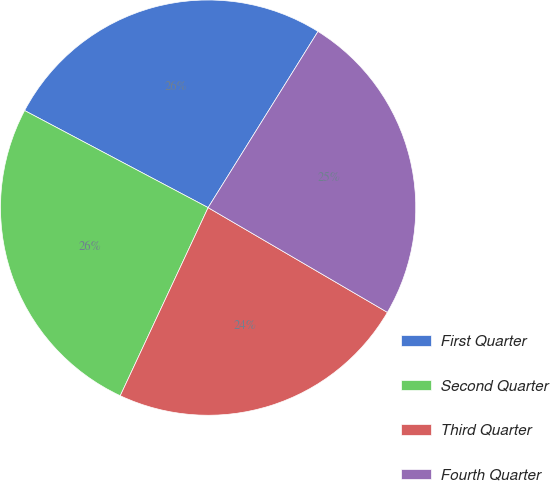Convert chart to OTSL. <chart><loc_0><loc_0><loc_500><loc_500><pie_chart><fcel>First Quarter<fcel>Second Quarter<fcel>Third Quarter<fcel>Fourth Quarter<nl><fcel>26.13%<fcel>25.79%<fcel>23.54%<fcel>24.54%<nl></chart> 